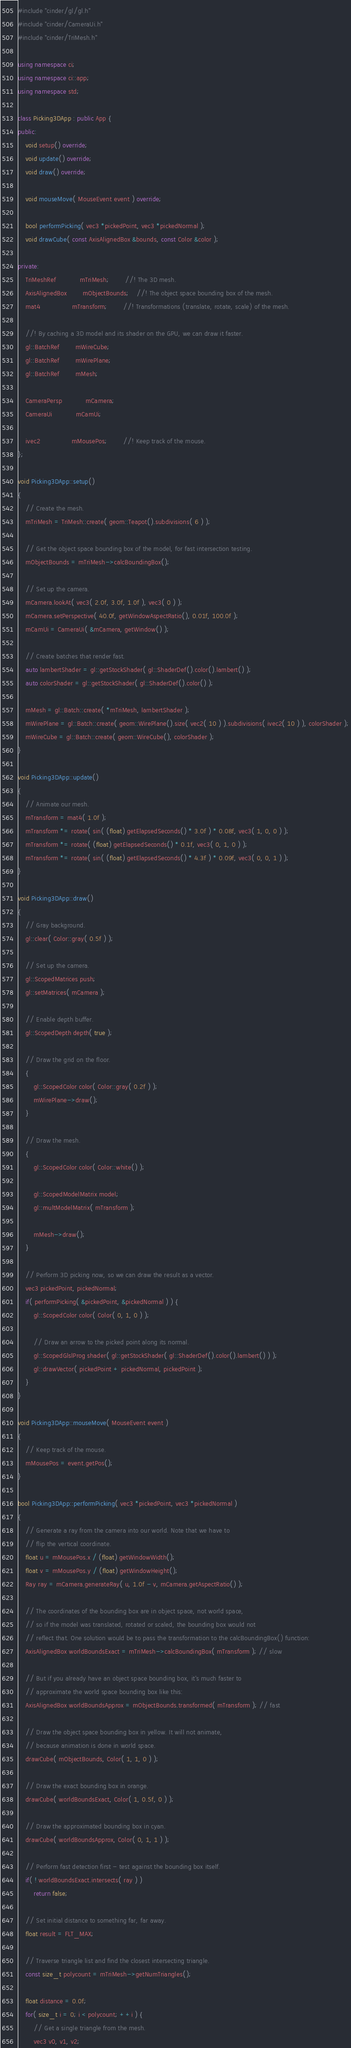<code> <loc_0><loc_0><loc_500><loc_500><_C++_>#include "cinder/gl/gl.h"
#include "cinder/CameraUi.h"
#include "cinder/TriMesh.h"

using namespace ci;
using namespace ci::app;
using namespace std;

class Picking3DApp : public App {
public:
	void setup() override;
	void update() override;
	void draw() override;

	void mouseMove( MouseEvent event ) override;

	bool performPicking( vec3 *pickedPoint, vec3 *pickedNormal );
	void drawCube( const AxisAlignedBox &bounds, const Color &color );

private:
	TriMeshRef			mTriMesh;		//! The 3D mesh.
	AxisAlignedBox		mObjectBounds; 	//! The object space bounding box of the mesh.
	mat4				mTransform;		//! Transformations (translate, rotate, scale) of the mesh.
										
	//! By caching a 3D model and its shader on the GPU, we can draw it faster.
	gl::BatchRef		mWireCube;		
	gl::BatchRef		mWirePlane;
	gl::BatchRef		mMesh;

	CameraPersp			mCamera;
	CameraUi			mCamUi;

	ivec2				mMousePos;		//! Keep track of the mouse.
};

void Picking3DApp::setup()
{
	// Create the mesh.
	mTriMesh = TriMesh::create( geom::Teapot().subdivisions( 6 ) );

	// Get the object space bounding box of the model, for fast intersection testing.
	mObjectBounds = mTriMesh->calcBoundingBox();

	// Set up the camera.
	mCamera.lookAt( vec3( 2.0f, 3.0f, 1.0f ), vec3( 0 ) );
	mCamera.setPerspective( 40.0f, getWindowAspectRatio(), 0.01f, 100.0f );
	mCamUi = CameraUi( &mCamera, getWindow() );

	// Create batches that render fast.
	auto lambertShader = gl::getStockShader( gl::ShaderDef().color().lambert() );
	auto colorShader = gl::getStockShader( gl::ShaderDef().color() );

	mMesh = gl::Batch::create( *mTriMesh, lambertShader );
	mWirePlane = gl::Batch::create( geom::WirePlane().size( vec2( 10 ) ).subdivisions( ivec2( 10 ) ), colorShader );
	mWireCube = gl::Batch::create( geom::WireCube(), colorShader );
}

void Picking3DApp::update()
{
	// Animate our mesh.
	mTransform = mat4( 1.0f );
	mTransform *= rotate( sin( (float) getElapsedSeconds() * 3.0f ) * 0.08f, vec3( 1, 0, 0 ) );
	mTransform *= rotate( (float) getElapsedSeconds() * 0.1f, vec3( 0, 1, 0 ) );
	mTransform *= rotate( sin( (float) getElapsedSeconds() * 4.3f ) * 0.09f, vec3( 0, 0, 1 ) );
}

void Picking3DApp::draw()
{
	// Gray background.
	gl::clear( Color::gray( 0.5f ) );

	// Set up the camera.
	gl::ScopedMatrices push;
	gl::setMatrices( mCamera );

	// Enable depth buffer.
	gl::ScopedDepth depth( true );

	// Draw the grid on the floor.
	{
		gl::ScopedColor color( Color::gray( 0.2f ) );
		mWirePlane->draw();
	}

	// Draw the mesh.
	{
		gl::ScopedColor color( Color::white() );

		gl::ScopedModelMatrix model;
		gl::multModelMatrix( mTransform );

		mMesh->draw();
	}

	// Perform 3D picking now, so we can draw the result as a vector.
	vec3 pickedPoint, pickedNormal;
	if( performPicking( &pickedPoint, &pickedNormal ) ) {
		gl::ScopedColor color( Color( 0, 1, 0 ) );

		// Draw an arrow to the picked point along its normal.
		gl::ScopedGlslProg shader( gl::getStockShader( gl::ShaderDef().color().lambert() ) );
		gl::drawVector( pickedPoint + pickedNormal, pickedPoint );
	}
}

void Picking3DApp::mouseMove( MouseEvent event )
{
	// Keep track of the mouse.
	mMousePos = event.getPos();
}

bool Picking3DApp::performPicking( vec3 *pickedPoint, vec3 *pickedNormal )
{
	// Generate a ray from the camera into our world. Note that we have to
	// flip the vertical coordinate.
	float u = mMousePos.x / (float) getWindowWidth();
	float v = mMousePos.y / (float) getWindowHeight();
	Ray ray = mCamera.generateRay( u, 1.0f - v, mCamera.getAspectRatio() );

	// The coordinates of the bounding box are in object space, not world space,
	// so if the model was translated, rotated or scaled, the bounding box would not
	// reflect that. One solution would be to pass the transformation to the calcBoundingBox() function:
	AxisAlignedBox worldBoundsExact = mTriMesh->calcBoundingBox( mTransform ); // slow

	// But if you already have an object space bounding box, it's much faster to
	// approximate the world space bounding box like this:
	AxisAlignedBox worldBoundsApprox = mObjectBounds.transformed( mTransform ); // fast

	// Draw the object space bounding box in yellow. It will not animate,
	// because animation is done in world space.
	drawCube( mObjectBounds, Color( 1, 1, 0 ) );

	// Draw the exact bounding box in orange.
	drawCube( worldBoundsExact, Color( 1, 0.5f, 0 ) );

	// Draw the approximated bounding box in cyan.
	drawCube( worldBoundsApprox, Color( 0, 1, 1 ) );

	// Perform fast detection first - test against the bounding box itself.
	if( ! worldBoundsExact.intersects( ray ) )
		return false;

	// Set initial distance to something far, far away.
	float result = FLT_MAX;

	// Traverse triangle list and find the closest intersecting triangle.
	const size_t polycount = mTriMesh->getNumTriangles();

	float distance = 0.0f;
	for( size_t i = 0; i < polycount; ++i ) {
		// Get a single triangle from the mesh.
		vec3 v0, v1, v2;</code> 